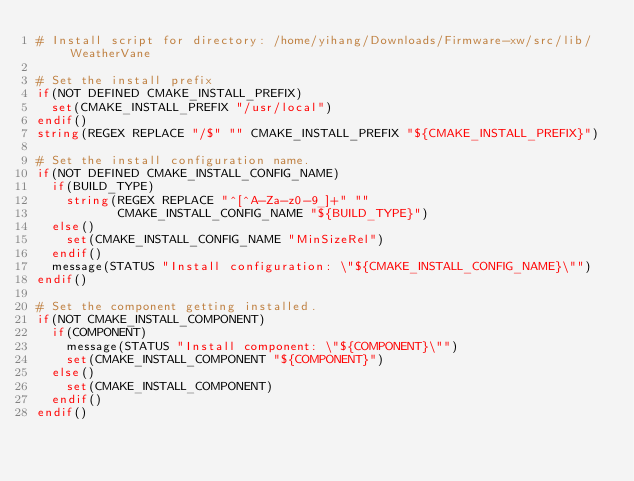<code> <loc_0><loc_0><loc_500><loc_500><_CMake_># Install script for directory: /home/yihang/Downloads/Firmware-xw/src/lib/WeatherVane

# Set the install prefix
if(NOT DEFINED CMAKE_INSTALL_PREFIX)
  set(CMAKE_INSTALL_PREFIX "/usr/local")
endif()
string(REGEX REPLACE "/$" "" CMAKE_INSTALL_PREFIX "${CMAKE_INSTALL_PREFIX}")

# Set the install configuration name.
if(NOT DEFINED CMAKE_INSTALL_CONFIG_NAME)
  if(BUILD_TYPE)
    string(REGEX REPLACE "^[^A-Za-z0-9_]+" ""
           CMAKE_INSTALL_CONFIG_NAME "${BUILD_TYPE}")
  else()
    set(CMAKE_INSTALL_CONFIG_NAME "MinSizeRel")
  endif()
  message(STATUS "Install configuration: \"${CMAKE_INSTALL_CONFIG_NAME}\"")
endif()

# Set the component getting installed.
if(NOT CMAKE_INSTALL_COMPONENT)
  if(COMPONENT)
    message(STATUS "Install component: \"${COMPONENT}\"")
    set(CMAKE_INSTALL_COMPONENT "${COMPONENT}")
  else()
    set(CMAKE_INSTALL_COMPONENT)
  endif()
endif()

</code> 